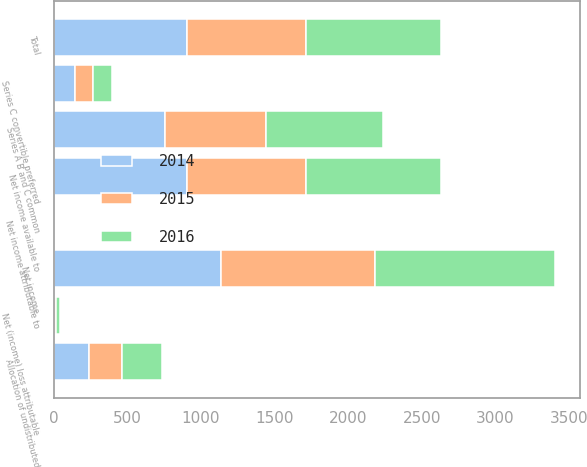Convert chart. <chart><loc_0><loc_0><loc_500><loc_500><stacked_bar_chart><ecel><fcel>Net income<fcel>Allocation of undistributed<fcel>Net income attributable to<fcel>Net (income) loss attributable<fcel>Net income available to<fcel>Series A B and C common<fcel>Series C convertible preferred<fcel>Total<nl><fcel>2016<fcel>1218<fcel>278<fcel>1<fcel>23<fcel>916<fcel>789<fcel>127<fcel>916<nl><fcel>2015<fcel>1048<fcel>224<fcel>1<fcel>13<fcel>810<fcel>686<fcel>124<fcel>810<nl><fcel>2014<fcel>1137<fcel>236<fcel>2<fcel>4<fcel>902<fcel>758<fcel>144<fcel>902<nl></chart> 